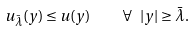Convert formula to latex. <formula><loc_0><loc_0><loc_500><loc_500>u _ { \bar { \lambda } } ( y ) \leq u ( y ) \quad \forall \ | y | \geq \bar { \lambda } .</formula> 